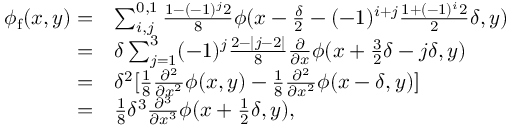<formula> <loc_0><loc_0><loc_500><loc_500>\begin{array} { r l } { \phi _ { f } ( x , y ) = } & { \sum _ { i , j } ^ { 0 , 1 } \frac { 1 - ( - 1 ) ^ { j } 2 } { 8 } \phi ( x - \frac { \delta } { 2 } - ( - 1 ) ^ { i + j } \frac { 1 + ( - 1 ) ^ { i } 2 } { 2 } \delta , y ) } \\ { = } & { \delta \sum _ { j = 1 } ^ { 3 } ( - 1 ) ^ { j } \frac { 2 - | j - 2 | } { 8 } \frac { \partial } { \partial x } \phi ( x + \frac { 3 } { 2 } \delta - j \delta , y ) } \\ { = } & { \delta ^ { 2 } [ \frac { 1 } { 8 } \frac { \partial ^ { 2 } } { \partial x ^ { 2 } } \phi ( x , y ) - \frac { 1 } { 8 } \frac { \partial ^ { 2 } } { \partial x ^ { 2 } } \phi ( x - \delta , y ) ] } \\ { = } & { \frac { 1 } { 8 } \delta ^ { 3 } \frac { \partial ^ { 3 } } { \partial x ^ { 3 } } \phi ( x + \frac { 1 } { 2 } \delta , y ) , } \end{array}</formula> 